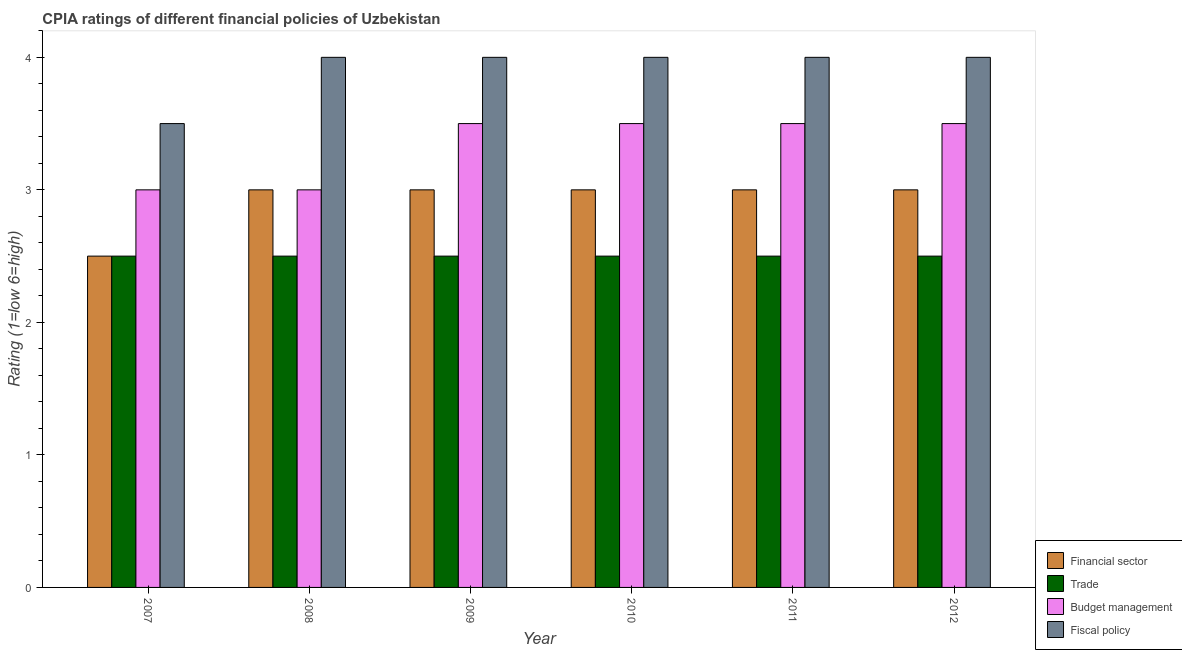How many different coloured bars are there?
Ensure brevity in your answer.  4. How many groups of bars are there?
Your answer should be compact. 6. Are the number of bars per tick equal to the number of legend labels?
Offer a very short reply. Yes. Are the number of bars on each tick of the X-axis equal?
Make the answer very short. Yes. In how many cases, is the number of bars for a given year not equal to the number of legend labels?
Provide a succinct answer. 0. Across all years, what is the minimum cpia rating of trade?
Keep it short and to the point. 2.5. In which year was the cpia rating of trade maximum?
Make the answer very short. 2007. What is the total cpia rating of budget management in the graph?
Your answer should be very brief. 20. What is the difference between the cpia rating of budget management in 2008 and that in 2010?
Your answer should be very brief. -0.5. What is the average cpia rating of financial sector per year?
Offer a terse response. 2.92. In how many years, is the cpia rating of budget management greater than 2.4?
Offer a terse response. 6. What is the difference between the highest and the lowest cpia rating of budget management?
Offer a very short reply. 0.5. What does the 3rd bar from the left in 2010 represents?
Your answer should be compact. Budget management. What does the 3rd bar from the right in 2007 represents?
Give a very brief answer. Trade. Is it the case that in every year, the sum of the cpia rating of financial sector and cpia rating of trade is greater than the cpia rating of budget management?
Ensure brevity in your answer.  Yes. Are all the bars in the graph horizontal?
Ensure brevity in your answer.  No. What is the difference between two consecutive major ticks on the Y-axis?
Your answer should be very brief. 1. Does the graph contain grids?
Your answer should be very brief. No. How many legend labels are there?
Offer a very short reply. 4. How are the legend labels stacked?
Provide a succinct answer. Vertical. What is the title of the graph?
Your response must be concise. CPIA ratings of different financial policies of Uzbekistan. Does "Miscellaneous expenses" appear as one of the legend labels in the graph?
Keep it short and to the point. No. What is the Rating (1=low 6=high) in Financial sector in 2007?
Keep it short and to the point. 2.5. What is the Rating (1=low 6=high) in Financial sector in 2008?
Ensure brevity in your answer.  3. What is the Rating (1=low 6=high) of Budget management in 2008?
Your answer should be compact. 3. What is the Rating (1=low 6=high) in Fiscal policy in 2008?
Make the answer very short. 4. What is the Rating (1=low 6=high) of Fiscal policy in 2009?
Your response must be concise. 4. What is the Rating (1=low 6=high) of Trade in 2010?
Give a very brief answer. 2.5. What is the Rating (1=low 6=high) in Fiscal policy in 2010?
Offer a very short reply. 4. What is the Rating (1=low 6=high) of Financial sector in 2011?
Ensure brevity in your answer.  3. What is the Rating (1=low 6=high) in Trade in 2011?
Your answer should be very brief. 2.5. What is the Rating (1=low 6=high) of Fiscal policy in 2012?
Keep it short and to the point. 4. Across all years, what is the maximum Rating (1=low 6=high) of Trade?
Your answer should be very brief. 2.5. Across all years, what is the maximum Rating (1=low 6=high) in Fiscal policy?
Offer a very short reply. 4. Across all years, what is the minimum Rating (1=low 6=high) in Financial sector?
Offer a terse response. 2.5. Across all years, what is the minimum Rating (1=low 6=high) of Fiscal policy?
Keep it short and to the point. 3.5. What is the total Rating (1=low 6=high) of Budget management in the graph?
Make the answer very short. 20. What is the difference between the Rating (1=low 6=high) in Financial sector in 2007 and that in 2008?
Give a very brief answer. -0.5. What is the difference between the Rating (1=low 6=high) of Fiscal policy in 2007 and that in 2008?
Make the answer very short. -0.5. What is the difference between the Rating (1=low 6=high) of Financial sector in 2007 and that in 2009?
Keep it short and to the point. -0.5. What is the difference between the Rating (1=low 6=high) in Trade in 2007 and that in 2009?
Offer a terse response. 0. What is the difference between the Rating (1=low 6=high) of Budget management in 2007 and that in 2009?
Your answer should be compact. -0.5. What is the difference between the Rating (1=low 6=high) in Budget management in 2007 and that in 2010?
Ensure brevity in your answer.  -0.5. What is the difference between the Rating (1=low 6=high) in Fiscal policy in 2007 and that in 2010?
Make the answer very short. -0.5. What is the difference between the Rating (1=low 6=high) of Trade in 2007 and that in 2011?
Provide a short and direct response. 0. What is the difference between the Rating (1=low 6=high) of Fiscal policy in 2007 and that in 2011?
Keep it short and to the point. -0.5. What is the difference between the Rating (1=low 6=high) in Fiscal policy in 2007 and that in 2012?
Make the answer very short. -0.5. What is the difference between the Rating (1=low 6=high) of Financial sector in 2008 and that in 2009?
Your answer should be very brief. 0. What is the difference between the Rating (1=low 6=high) in Trade in 2008 and that in 2009?
Keep it short and to the point. 0. What is the difference between the Rating (1=low 6=high) of Budget management in 2008 and that in 2009?
Your response must be concise. -0.5. What is the difference between the Rating (1=low 6=high) of Trade in 2008 and that in 2010?
Your answer should be very brief. 0. What is the difference between the Rating (1=low 6=high) in Budget management in 2008 and that in 2010?
Give a very brief answer. -0.5. What is the difference between the Rating (1=low 6=high) in Fiscal policy in 2008 and that in 2010?
Your response must be concise. 0. What is the difference between the Rating (1=low 6=high) of Trade in 2008 and that in 2011?
Make the answer very short. 0. What is the difference between the Rating (1=low 6=high) of Trade in 2008 and that in 2012?
Your answer should be very brief. 0. What is the difference between the Rating (1=low 6=high) of Budget management in 2008 and that in 2012?
Provide a succinct answer. -0.5. What is the difference between the Rating (1=low 6=high) of Fiscal policy in 2009 and that in 2010?
Your answer should be compact. 0. What is the difference between the Rating (1=low 6=high) of Budget management in 2009 and that in 2011?
Ensure brevity in your answer.  0. What is the difference between the Rating (1=low 6=high) in Fiscal policy in 2009 and that in 2011?
Offer a terse response. 0. What is the difference between the Rating (1=low 6=high) of Trade in 2009 and that in 2012?
Offer a terse response. 0. What is the difference between the Rating (1=low 6=high) of Fiscal policy in 2009 and that in 2012?
Offer a terse response. 0. What is the difference between the Rating (1=low 6=high) in Financial sector in 2010 and that in 2011?
Your answer should be very brief. 0. What is the difference between the Rating (1=low 6=high) of Trade in 2010 and that in 2011?
Provide a short and direct response. 0. What is the difference between the Rating (1=low 6=high) in Budget management in 2010 and that in 2012?
Your response must be concise. 0. What is the difference between the Rating (1=low 6=high) in Fiscal policy in 2010 and that in 2012?
Provide a short and direct response. 0. What is the difference between the Rating (1=low 6=high) of Fiscal policy in 2011 and that in 2012?
Offer a very short reply. 0. What is the difference between the Rating (1=low 6=high) of Trade in 2007 and the Rating (1=low 6=high) of Budget management in 2008?
Offer a very short reply. -0.5. What is the difference between the Rating (1=low 6=high) of Trade in 2007 and the Rating (1=low 6=high) of Fiscal policy in 2008?
Make the answer very short. -1.5. What is the difference between the Rating (1=low 6=high) in Financial sector in 2007 and the Rating (1=low 6=high) in Trade in 2009?
Your answer should be compact. 0. What is the difference between the Rating (1=low 6=high) of Financial sector in 2007 and the Rating (1=low 6=high) of Budget management in 2009?
Offer a very short reply. -1. What is the difference between the Rating (1=low 6=high) of Financial sector in 2007 and the Rating (1=low 6=high) of Fiscal policy in 2009?
Your answer should be very brief. -1.5. What is the difference between the Rating (1=low 6=high) in Trade in 2007 and the Rating (1=low 6=high) in Budget management in 2009?
Provide a short and direct response. -1. What is the difference between the Rating (1=low 6=high) in Trade in 2007 and the Rating (1=low 6=high) in Fiscal policy in 2009?
Your answer should be compact. -1.5. What is the difference between the Rating (1=low 6=high) in Budget management in 2007 and the Rating (1=low 6=high) in Fiscal policy in 2009?
Provide a succinct answer. -1. What is the difference between the Rating (1=low 6=high) of Financial sector in 2007 and the Rating (1=low 6=high) of Trade in 2010?
Offer a terse response. 0. What is the difference between the Rating (1=low 6=high) of Financial sector in 2007 and the Rating (1=low 6=high) of Budget management in 2010?
Give a very brief answer. -1. What is the difference between the Rating (1=low 6=high) of Financial sector in 2007 and the Rating (1=low 6=high) of Trade in 2011?
Your answer should be compact. 0. What is the difference between the Rating (1=low 6=high) in Financial sector in 2007 and the Rating (1=low 6=high) in Fiscal policy in 2011?
Your answer should be compact. -1.5. What is the difference between the Rating (1=low 6=high) of Trade in 2007 and the Rating (1=low 6=high) of Budget management in 2011?
Ensure brevity in your answer.  -1. What is the difference between the Rating (1=low 6=high) of Trade in 2007 and the Rating (1=low 6=high) of Fiscal policy in 2011?
Your answer should be compact. -1.5. What is the difference between the Rating (1=low 6=high) in Budget management in 2007 and the Rating (1=low 6=high) in Fiscal policy in 2011?
Keep it short and to the point. -1. What is the difference between the Rating (1=low 6=high) of Financial sector in 2007 and the Rating (1=low 6=high) of Fiscal policy in 2012?
Your response must be concise. -1.5. What is the difference between the Rating (1=low 6=high) of Trade in 2007 and the Rating (1=low 6=high) of Budget management in 2012?
Your response must be concise. -1. What is the difference between the Rating (1=low 6=high) in Trade in 2007 and the Rating (1=low 6=high) in Fiscal policy in 2012?
Make the answer very short. -1.5. What is the difference between the Rating (1=low 6=high) in Budget management in 2007 and the Rating (1=low 6=high) in Fiscal policy in 2012?
Give a very brief answer. -1. What is the difference between the Rating (1=low 6=high) in Financial sector in 2008 and the Rating (1=low 6=high) in Budget management in 2009?
Keep it short and to the point. -0.5. What is the difference between the Rating (1=low 6=high) of Financial sector in 2008 and the Rating (1=low 6=high) of Fiscal policy in 2009?
Keep it short and to the point. -1. What is the difference between the Rating (1=low 6=high) in Trade in 2008 and the Rating (1=low 6=high) in Budget management in 2009?
Make the answer very short. -1. What is the difference between the Rating (1=low 6=high) of Trade in 2008 and the Rating (1=low 6=high) of Fiscal policy in 2010?
Offer a terse response. -1.5. What is the difference between the Rating (1=low 6=high) in Budget management in 2008 and the Rating (1=low 6=high) in Fiscal policy in 2010?
Give a very brief answer. -1. What is the difference between the Rating (1=low 6=high) in Financial sector in 2008 and the Rating (1=low 6=high) in Trade in 2012?
Give a very brief answer. 0.5. What is the difference between the Rating (1=low 6=high) of Financial sector in 2008 and the Rating (1=low 6=high) of Budget management in 2012?
Your answer should be compact. -0.5. What is the difference between the Rating (1=low 6=high) of Budget management in 2008 and the Rating (1=low 6=high) of Fiscal policy in 2012?
Provide a short and direct response. -1. What is the difference between the Rating (1=low 6=high) in Financial sector in 2009 and the Rating (1=low 6=high) in Budget management in 2010?
Ensure brevity in your answer.  -0.5. What is the difference between the Rating (1=low 6=high) of Budget management in 2009 and the Rating (1=low 6=high) of Fiscal policy in 2010?
Make the answer very short. -0.5. What is the difference between the Rating (1=low 6=high) of Financial sector in 2009 and the Rating (1=low 6=high) of Trade in 2011?
Provide a succinct answer. 0.5. What is the difference between the Rating (1=low 6=high) of Trade in 2009 and the Rating (1=low 6=high) of Fiscal policy in 2011?
Provide a succinct answer. -1.5. What is the difference between the Rating (1=low 6=high) in Budget management in 2009 and the Rating (1=low 6=high) in Fiscal policy in 2011?
Make the answer very short. -0.5. What is the difference between the Rating (1=low 6=high) in Financial sector in 2009 and the Rating (1=low 6=high) in Budget management in 2012?
Make the answer very short. -0.5. What is the difference between the Rating (1=low 6=high) in Trade in 2009 and the Rating (1=low 6=high) in Budget management in 2012?
Provide a short and direct response. -1. What is the difference between the Rating (1=low 6=high) in Budget management in 2009 and the Rating (1=low 6=high) in Fiscal policy in 2012?
Give a very brief answer. -0.5. What is the difference between the Rating (1=low 6=high) of Trade in 2010 and the Rating (1=low 6=high) of Fiscal policy in 2011?
Your answer should be compact. -1.5. What is the difference between the Rating (1=low 6=high) in Budget management in 2010 and the Rating (1=low 6=high) in Fiscal policy in 2011?
Your answer should be very brief. -0.5. What is the difference between the Rating (1=low 6=high) in Financial sector in 2010 and the Rating (1=low 6=high) in Trade in 2012?
Your answer should be compact. 0.5. What is the difference between the Rating (1=low 6=high) in Financial sector in 2010 and the Rating (1=low 6=high) in Budget management in 2012?
Make the answer very short. -0.5. What is the difference between the Rating (1=low 6=high) of Financial sector in 2010 and the Rating (1=low 6=high) of Fiscal policy in 2012?
Give a very brief answer. -1. What is the difference between the Rating (1=low 6=high) of Trade in 2010 and the Rating (1=low 6=high) of Budget management in 2012?
Ensure brevity in your answer.  -1. What is the difference between the Rating (1=low 6=high) in Trade in 2010 and the Rating (1=low 6=high) in Fiscal policy in 2012?
Provide a succinct answer. -1.5. What is the difference between the Rating (1=low 6=high) of Budget management in 2010 and the Rating (1=low 6=high) of Fiscal policy in 2012?
Make the answer very short. -0.5. What is the difference between the Rating (1=low 6=high) of Financial sector in 2011 and the Rating (1=low 6=high) of Trade in 2012?
Make the answer very short. 0.5. What is the difference between the Rating (1=low 6=high) in Financial sector in 2011 and the Rating (1=low 6=high) in Fiscal policy in 2012?
Offer a terse response. -1. What is the difference between the Rating (1=low 6=high) in Trade in 2011 and the Rating (1=low 6=high) in Budget management in 2012?
Your answer should be very brief. -1. What is the difference between the Rating (1=low 6=high) in Trade in 2011 and the Rating (1=low 6=high) in Fiscal policy in 2012?
Your response must be concise. -1.5. What is the difference between the Rating (1=low 6=high) of Budget management in 2011 and the Rating (1=low 6=high) of Fiscal policy in 2012?
Your answer should be very brief. -0.5. What is the average Rating (1=low 6=high) of Financial sector per year?
Provide a short and direct response. 2.92. What is the average Rating (1=low 6=high) of Fiscal policy per year?
Give a very brief answer. 3.92. In the year 2007, what is the difference between the Rating (1=low 6=high) in Financial sector and Rating (1=low 6=high) in Trade?
Your response must be concise. 0. In the year 2007, what is the difference between the Rating (1=low 6=high) of Financial sector and Rating (1=low 6=high) of Fiscal policy?
Offer a very short reply. -1. In the year 2007, what is the difference between the Rating (1=low 6=high) of Trade and Rating (1=low 6=high) of Budget management?
Give a very brief answer. -0.5. In the year 2008, what is the difference between the Rating (1=low 6=high) of Trade and Rating (1=low 6=high) of Budget management?
Offer a very short reply. -0.5. In the year 2008, what is the difference between the Rating (1=low 6=high) in Budget management and Rating (1=low 6=high) in Fiscal policy?
Ensure brevity in your answer.  -1. In the year 2009, what is the difference between the Rating (1=low 6=high) in Financial sector and Rating (1=low 6=high) in Fiscal policy?
Give a very brief answer. -1. In the year 2009, what is the difference between the Rating (1=low 6=high) of Trade and Rating (1=low 6=high) of Fiscal policy?
Offer a very short reply. -1.5. In the year 2010, what is the difference between the Rating (1=low 6=high) of Financial sector and Rating (1=low 6=high) of Fiscal policy?
Make the answer very short. -1. In the year 2010, what is the difference between the Rating (1=low 6=high) in Trade and Rating (1=low 6=high) in Fiscal policy?
Give a very brief answer. -1.5. In the year 2010, what is the difference between the Rating (1=low 6=high) of Budget management and Rating (1=low 6=high) of Fiscal policy?
Your response must be concise. -0.5. In the year 2011, what is the difference between the Rating (1=low 6=high) in Financial sector and Rating (1=low 6=high) in Trade?
Provide a short and direct response. 0.5. In the year 2011, what is the difference between the Rating (1=low 6=high) in Financial sector and Rating (1=low 6=high) in Budget management?
Offer a very short reply. -0.5. In the year 2011, what is the difference between the Rating (1=low 6=high) in Trade and Rating (1=low 6=high) in Budget management?
Your answer should be very brief. -1. In the year 2012, what is the difference between the Rating (1=low 6=high) in Financial sector and Rating (1=low 6=high) in Trade?
Provide a succinct answer. 0.5. In the year 2012, what is the difference between the Rating (1=low 6=high) of Budget management and Rating (1=low 6=high) of Fiscal policy?
Your answer should be compact. -0.5. What is the ratio of the Rating (1=low 6=high) of Fiscal policy in 2007 to that in 2008?
Your answer should be compact. 0.88. What is the ratio of the Rating (1=low 6=high) of Financial sector in 2007 to that in 2010?
Keep it short and to the point. 0.83. What is the ratio of the Rating (1=low 6=high) of Budget management in 2007 to that in 2010?
Provide a succinct answer. 0.86. What is the ratio of the Rating (1=low 6=high) in Fiscal policy in 2007 to that in 2010?
Your response must be concise. 0.88. What is the ratio of the Rating (1=low 6=high) of Trade in 2007 to that in 2011?
Your answer should be compact. 1. What is the ratio of the Rating (1=low 6=high) of Budget management in 2007 to that in 2011?
Offer a very short reply. 0.86. What is the ratio of the Rating (1=low 6=high) in Fiscal policy in 2007 to that in 2011?
Your response must be concise. 0.88. What is the ratio of the Rating (1=low 6=high) in Financial sector in 2007 to that in 2012?
Ensure brevity in your answer.  0.83. What is the ratio of the Rating (1=low 6=high) of Trade in 2007 to that in 2012?
Your answer should be compact. 1. What is the ratio of the Rating (1=low 6=high) in Budget management in 2007 to that in 2012?
Give a very brief answer. 0.86. What is the ratio of the Rating (1=low 6=high) of Fiscal policy in 2007 to that in 2012?
Your answer should be very brief. 0.88. What is the ratio of the Rating (1=low 6=high) in Budget management in 2008 to that in 2009?
Offer a very short reply. 0.86. What is the ratio of the Rating (1=low 6=high) in Financial sector in 2008 to that in 2010?
Offer a terse response. 1. What is the ratio of the Rating (1=low 6=high) of Financial sector in 2008 to that in 2011?
Provide a succinct answer. 1. What is the ratio of the Rating (1=low 6=high) in Trade in 2008 to that in 2011?
Provide a succinct answer. 1. What is the ratio of the Rating (1=low 6=high) in Budget management in 2008 to that in 2011?
Make the answer very short. 0.86. What is the ratio of the Rating (1=low 6=high) in Fiscal policy in 2008 to that in 2012?
Your answer should be compact. 1. What is the ratio of the Rating (1=low 6=high) of Trade in 2009 to that in 2011?
Keep it short and to the point. 1. What is the ratio of the Rating (1=low 6=high) in Financial sector in 2009 to that in 2012?
Offer a very short reply. 1. What is the ratio of the Rating (1=low 6=high) in Trade in 2009 to that in 2012?
Your answer should be compact. 1. What is the ratio of the Rating (1=low 6=high) in Budget management in 2009 to that in 2012?
Your answer should be compact. 1. What is the ratio of the Rating (1=low 6=high) in Budget management in 2010 to that in 2011?
Make the answer very short. 1. What is the ratio of the Rating (1=low 6=high) of Fiscal policy in 2010 to that in 2011?
Provide a succinct answer. 1. What is the ratio of the Rating (1=low 6=high) of Budget management in 2010 to that in 2012?
Give a very brief answer. 1. What is the ratio of the Rating (1=low 6=high) in Fiscal policy in 2010 to that in 2012?
Provide a succinct answer. 1. What is the ratio of the Rating (1=low 6=high) in Financial sector in 2011 to that in 2012?
Provide a succinct answer. 1. What is the ratio of the Rating (1=low 6=high) of Trade in 2011 to that in 2012?
Your response must be concise. 1. What is the difference between the highest and the second highest Rating (1=low 6=high) in Trade?
Your response must be concise. 0. What is the difference between the highest and the second highest Rating (1=low 6=high) in Budget management?
Provide a short and direct response. 0. What is the difference between the highest and the lowest Rating (1=low 6=high) in Trade?
Offer a very short reply. 0. 